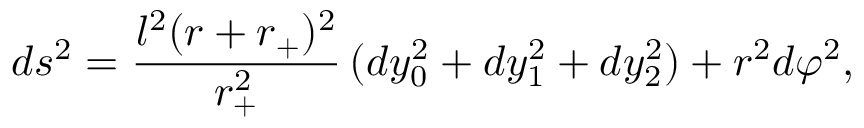<formula> <loc_0><loc_0><loc_500><loc_500>d s ^ { 2 } = \frac { l ^ { 2 } ( r + r _ { + } ) ^ { 2 } } { r _ { + } ^ { 2 } } \, ( d y _ { 0 } ^ { 2 } + d y _ { 1 } ^ { 2 } + d y _ { 2 } ^ { 2 } ) + r ^ { 2 } d \varphi ^ { 2 } ,</formula> 